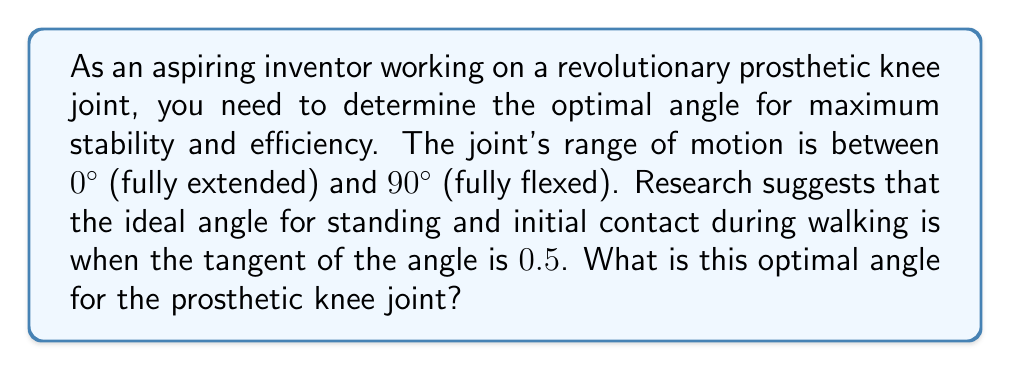Can you answer this question? To solve this problem, we need to use the inverse tangent function (arctangent or $\tan^{-1}$) to find the angle whose tangent is 0.5.

1) We are given that $\tan(\theta) = 0.5$, where $\theta$ is the optimal angle we're looking for.

2) To find $\theta$, we apply the inverse tangent function to both sides:

   $$\theta = \tan^{-1}(0.5)$$

3) Using a calculator or trigonometric tables, we can evaluate this:

   $$\theta \approx 26.57°$$

4) To verify, we can check that $\tan(26.57°) \approx 0.5$

5) It's important to note that this angle falls within the given range of motion (0° to 90°) for the prosthetic knee joint.

This angle represents the optimal position for the prosthetic knee joint during standing and at the initial contact phase of walking, balancing stability and efficiency.

[asy]
import geometry;

size(200);
draw((-1,0)--(3,0),Arrow);
draw((0,-0.5)--(0,2),Arrow);

real theta = atan(0.5);
draw((0,0)--(2,1),red);
draw((2,0)--(2,1),dashed);
draw(arc((0,0),0.5,0,degrees(theta)),blue);

label("$\theta$", (0.3,0.2), NE);
label("1", (2,0.5), E);
label("0.5", (1,1), N);

dot((2,1));
[/asy]
Answer: The optimal angle for the prosthetic knee joint is approximately $26.57°$. 